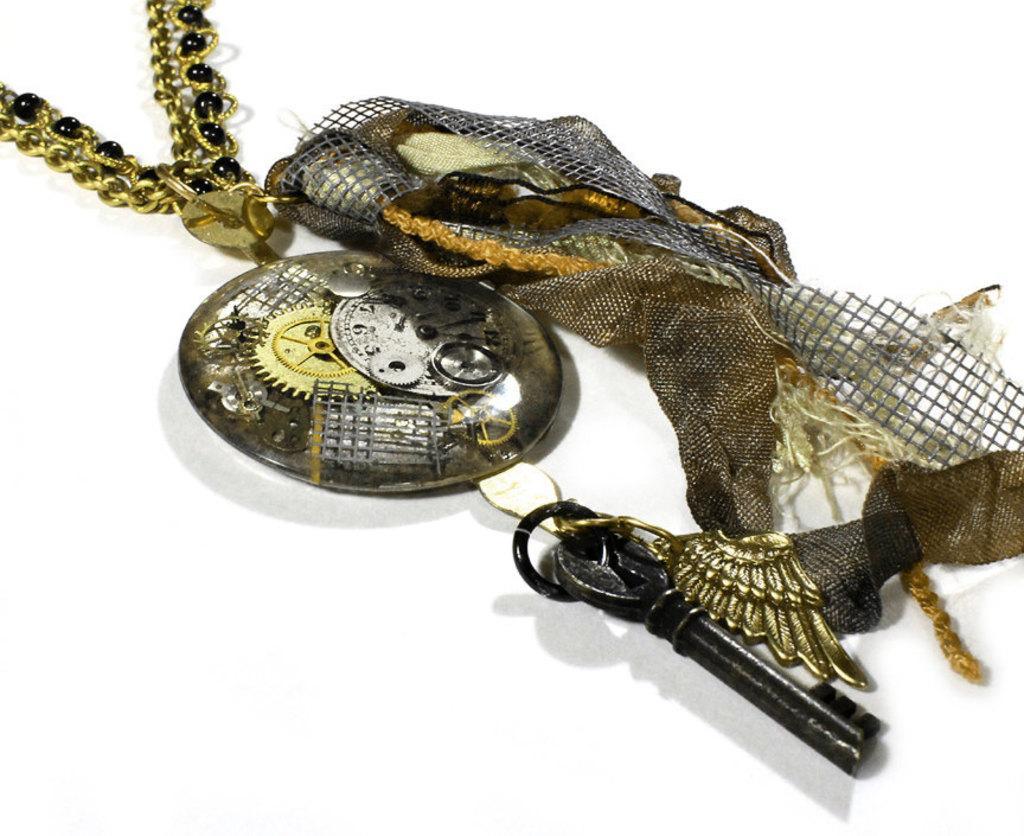Can you describe this image briefly? In this picture there is a key and there is a cloth and there is a chain. At the back there is a white background. 